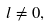<formula> <loc_0><loc_0><loc_500><loc_500>l \neq 0 ,</formula> 